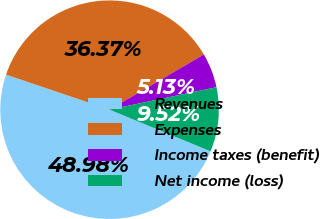Convert chart to OTSL. <chart><loc_0><loc_0><loc_500><loc_500><pie_chart><fcel>Revenues<fcel>Expenses<fcel>Income taxes (benefit)<fcel>Net income (loss)<nl><fcel>48.98%<fcel>36.37%<fcel>5.13%<fcel>9.52%<nl></chart> 